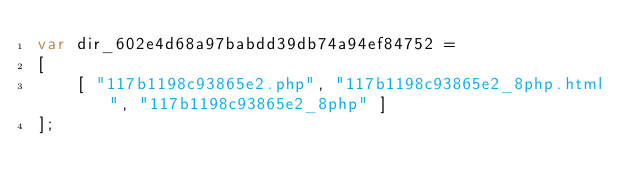<code> <loc_0><loc_0><loc_500><loc_500><_JavaScript_>var dir_602e4d68a97babdd39db74a94ef84752 =
[
    [ "117b1198c93865e2.php", "117b1198c93865e2_8php.html", "117b1198c93865e2_8php" ]
];</code> 